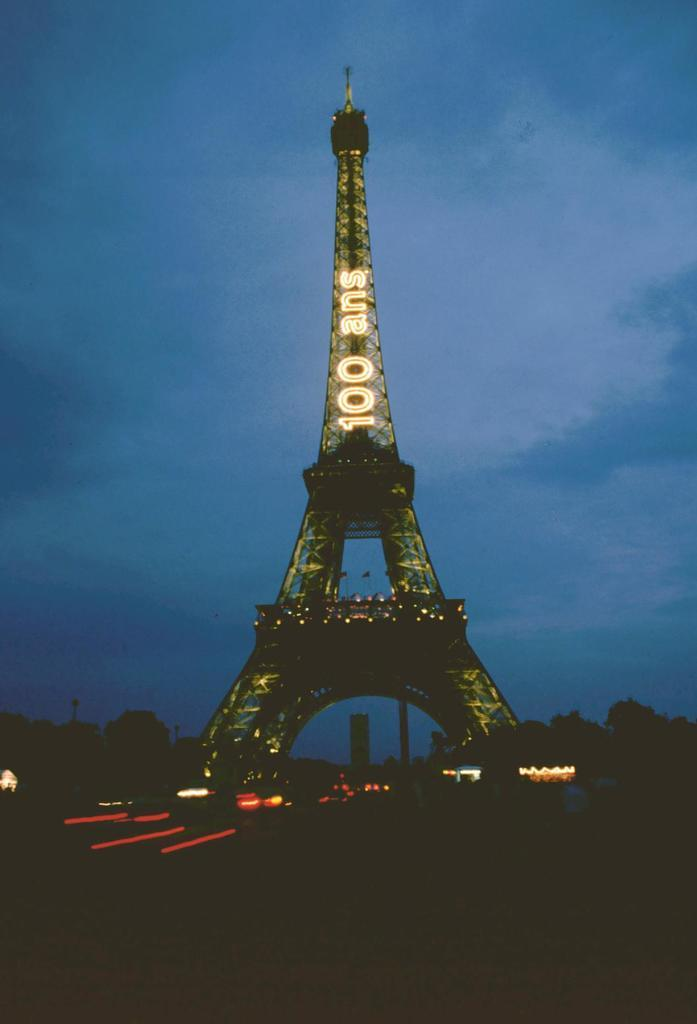What famous landmark can be seen in the image? The Eiffel tower is present in the image. What type of vegetation is visible in the image? There are trees in the image. What are the flags attached to in the image? The flags are attached to poles in the image. What can be used to illuminate the area in the image? There are lights in the image. What is visible in the background of the image? The sky with clouds is visible in the background of the image. Can you spot any plants or a robin in the image? There are no plants or robins present in the image. Is there a snake visible in the image? There is no snake present in the image. 